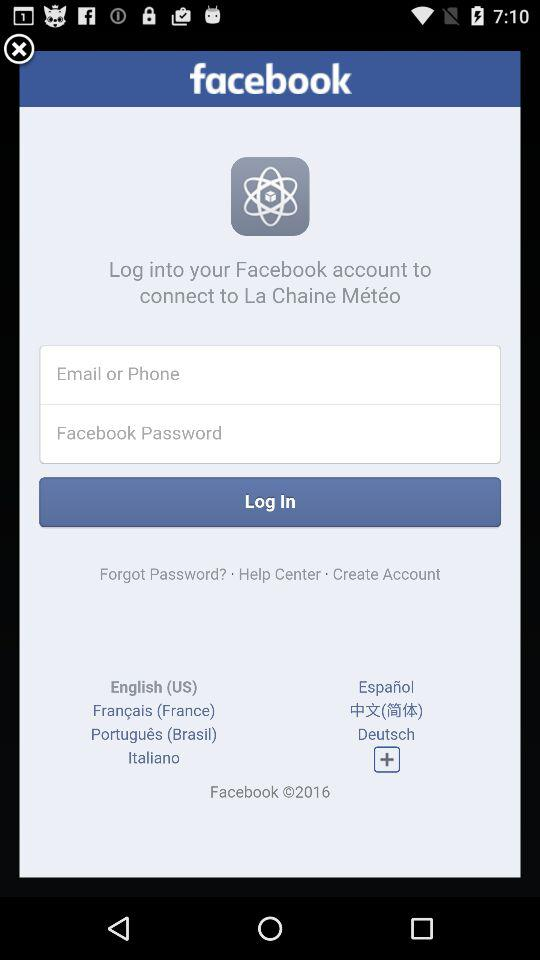What are the requirements to get a login? The requirements to get a login are "Email or Phone" and "Facebook Password". 